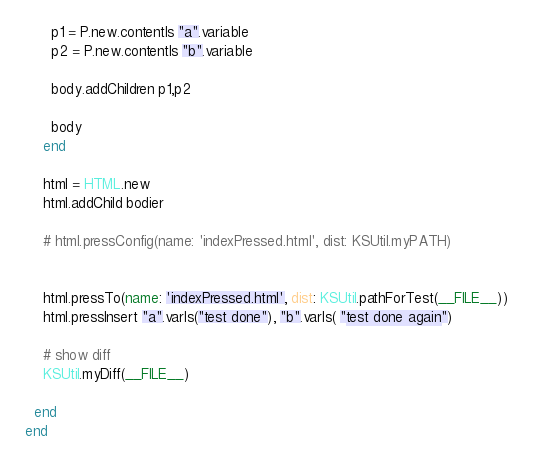Convert code to text. <code><loc_0><loc_0><loc_500><loc_500><_Ruby_>      p1 = P.new.contentIs "a".variable
      p2 = P.new.contentIs "b".variable
      
      body.addChildren p1,p2
      
      body
    end
    
    html = HTML.new
    html.addChild bodier

    # html.pressConfig(name: 'indexPressed.html', dist: KSUtil.myPATH)

    
    html.pressTo(name: 'indexPressed.html', dist: KSUtil.pathForTest(__FILE__))
    html.pressInsert "a".varIs("test done"), "b".varIs( "test done again")
    
    # show diff    
    KSUtil.myDiff(__FILE__)

  end
end
</code> 